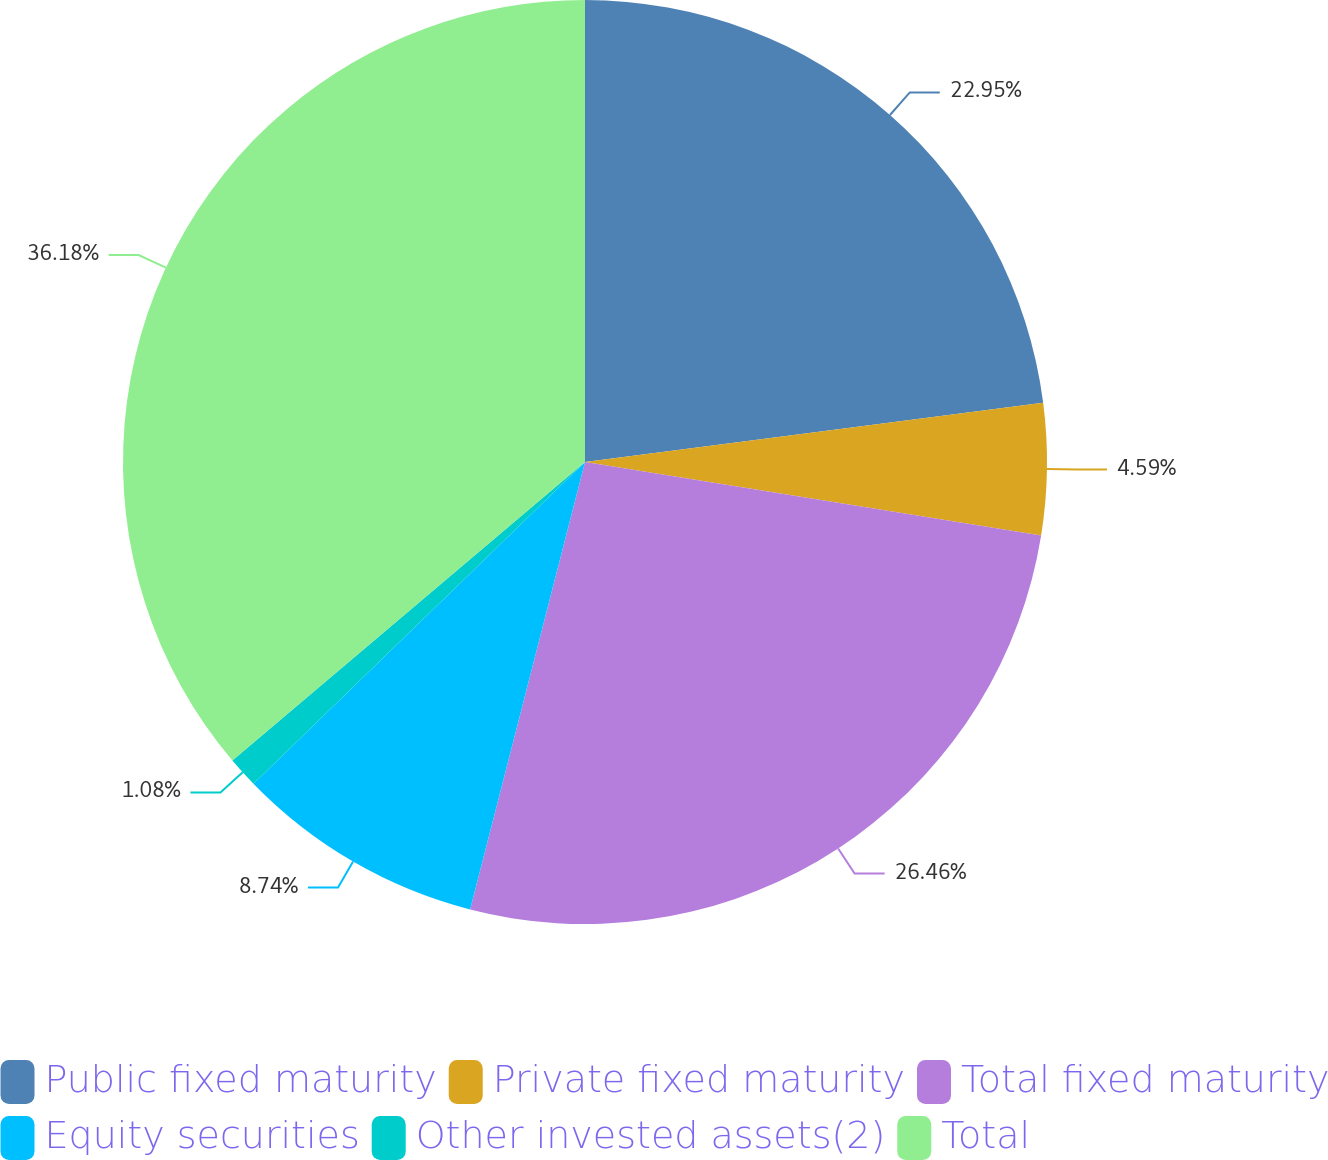Convert chart to OTSL. <chart><loc_0><loc_0><loc_500><loc_500><pie_chart><fcel>Public fixed maturity<fcel>Private fixed maturity<fcel>Total fixed maturity<fcel>Equity securities<fcel>Other invested assets(2)<fcel>Total<nl><fcel>22.95%<fcel>4.59%<fcel>26.46%<fcel>8.74%<fcel>1.08%<fcel>36.18%<nl></chart> 